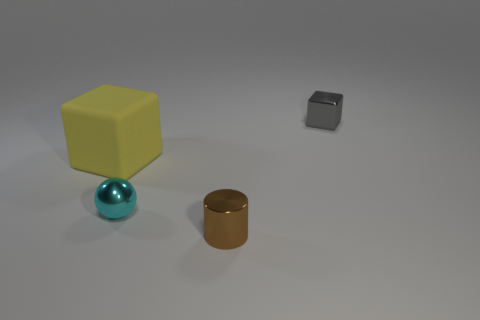What is the size of the yellow block?
Provide a succinct answer. Large. What color is the shiny ball that is the same size as the brown metallic cylinder?
Offer a very short reply. Cyan. Is there a shiny block of the same color as the rubber thing?
Make the answer very short. No. What material is the small sphere?
Give a very brief answer. Metal. What number of tiny green metallic cylinders are there?
Provide a succinct answer. 0. Is the color of the thing that is left of the cyan thing the same as the object behind the yellow cube?
Your response must be concise. No. How many other objects are there of the same size as the metallic cylinder?
Keep it short and to the point. 2. The tiny metal thing that is in front of the small cyan metal thing is what color?
Your answer should be compact. Brown. Does the cube in front of the gray block have the same material as the cylinder?
Your answer should be compact. No. How many small shiny things are right of the tiny brown cylinder and in front of the tiny metallic block?
Offer a very short reply. 0. 